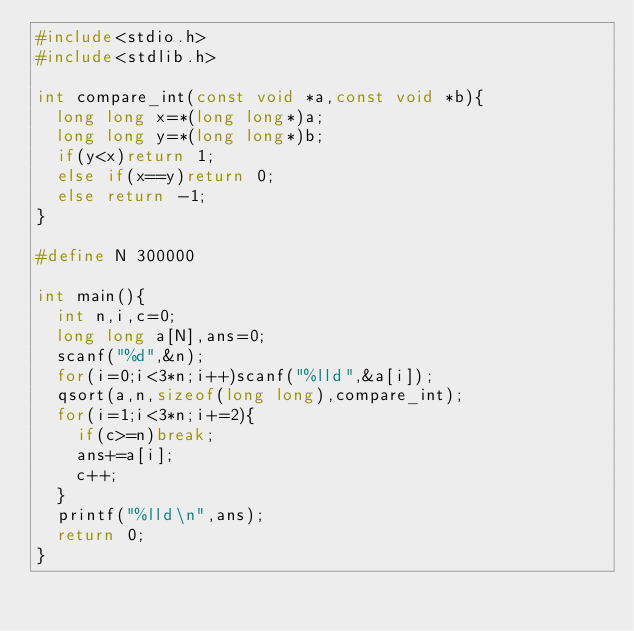<code> <loc_0><loc_0><loc_500><loc_500><_C_>#include<stdio.h>
#include<stdlib.h>

int compare_int(const void *a,const void *b){
	long long x=*(long long*)a;
	long long y=*(long long*)b;
	if(y<x)return 1;
	else if(x==y)return 0;
	else return -1;
}

#define N 300000

int main(){
	int n,i,c=0;
	long long a[N],ans=0;
	scanf("%d",&n);
	for(i=0;i<3*n;i++)scanf("%lld",&a[i]);
	qsort(a,n,sizeof(long long),compare_int);
	for(i=1;i<3*n;i+=2){
		if(c>=n)break;
		ans+=a[i];
		c++;
	}
	printf("%lld\n",ans);
	return 0;
}</code> 